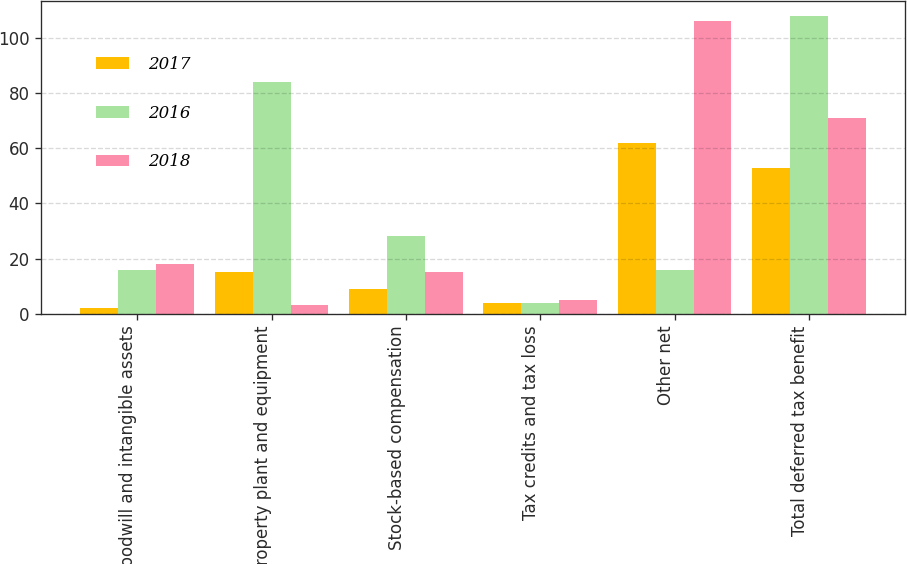Convert chart to OTSL. <chart><loc_0><loc_0><loc_500><loc_500><stacked_bar_chart><ecel><fcel>Goodwill and intangible assets<fcel>Property plant and equipment<fcel>Stock-based compensation<fcel>Tax credits and tax loss<fcel>Other net<fcel>Total deferred tax benefit<nl><fcel>2017<fcel>2<fcel>15<fcel>9<fcel>4<fcel>62<fcel>53<nl><fcel>2016<fcel>16<fcel>84<fcel>28<fcel>4<fcel>16<fcel>108<nl><fcel>2018<fcel>18<fcel>3<fcel>15<fcel>5<fcel>106<fcel>71<nl></chart> 